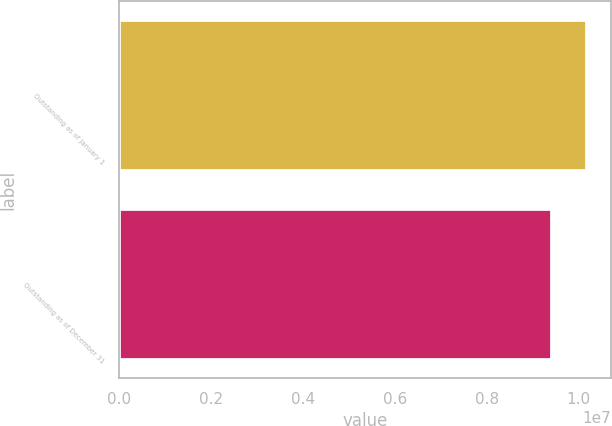Convert chart to OTSL. <chart><loc_0><loc_0><loc_500><loc_500><bar_chart><fcel>Outstanding as of January 1<fcel>Outstanding as of December 31<nl><fcel>1.01908e+07<fcel>9.41704e+06<nl></chart> 